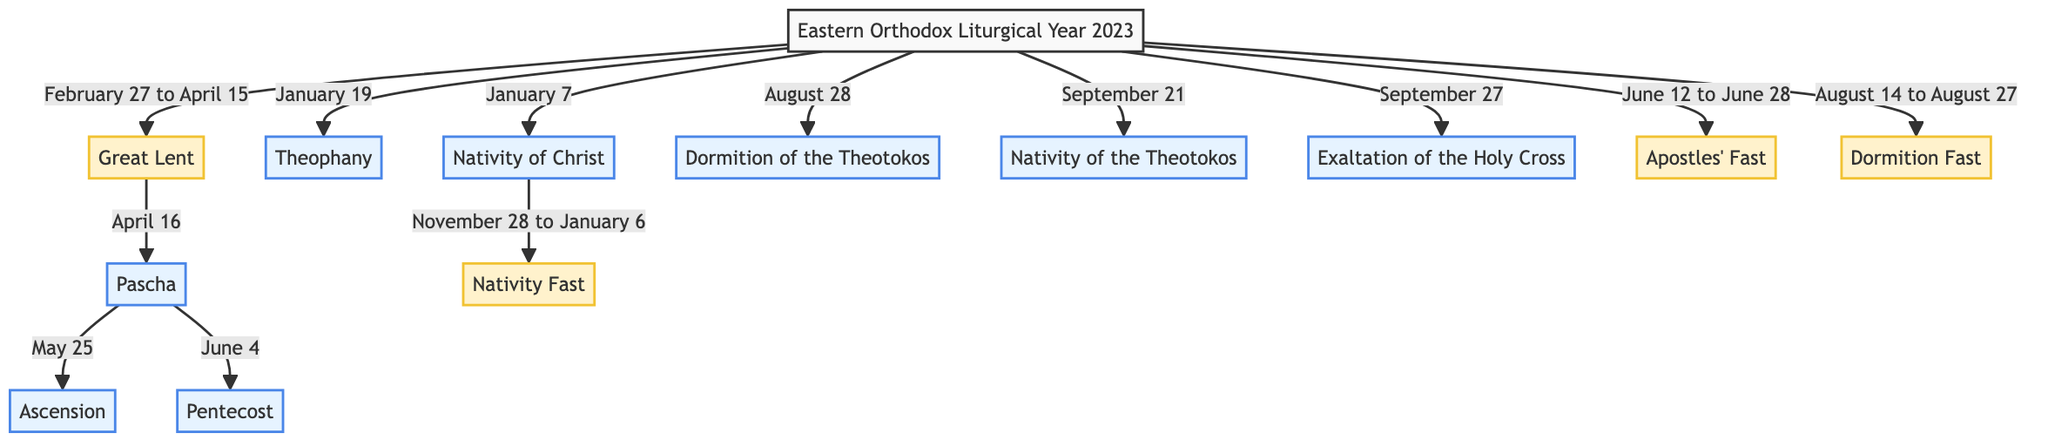What is the first major feast day in the 2023 liturgical calendar? The diagram shows that the first major feast day occurs on January 7, which is the Nativity of Christ.
Answer: Nativity of Christ How long does Great Lent last in 2023? According to the diagram, Great Lent starts on February 27 and ends on April 15, which is a duration of 49 days.
Answer: 49 days On which date is Pascha celebrated in 2023? The flowchart indicates that Pascha is celebrated on April 16, following Great Lent.
Answer: April 16 How many fasting periods are indicated in the diagram? The diagram has three fasting periods: Great Lent, Nativity Fast, Apostles' Fast, and Dormition Fast. This totals to four fasting periods.
Answer: 4 What is the feast day that follows Ascension in 2023? According to the diagram, after Ascension, the next significant feast day is Pentecost, celebrated on June 4.
Answer: Pentecost What is the duration of the Nativity Fast in 2023? The diagram specifies that the Nativity Fast runs from November 28 to January 6, making the duration 40 days.
Answer: 40 days Which feast occurs on August 28? The diagram identifies the Dormition of the Theotokos as the feast that occurs on August 28.
Answer: Dormition of the Theotokos How many major feast days are highlighted in the diagram? The diagram highlights a total of eight major feast days throughout the liturgical calendar for 2023.
Answer: 8 What is the relationship between Great Lent and Pascha? The diagram illustrates that Great Lent leads directly to Pascha, with Pascha occurring immediately after the end of Great Lent.
Answer: Great Lent leads to Pascha 